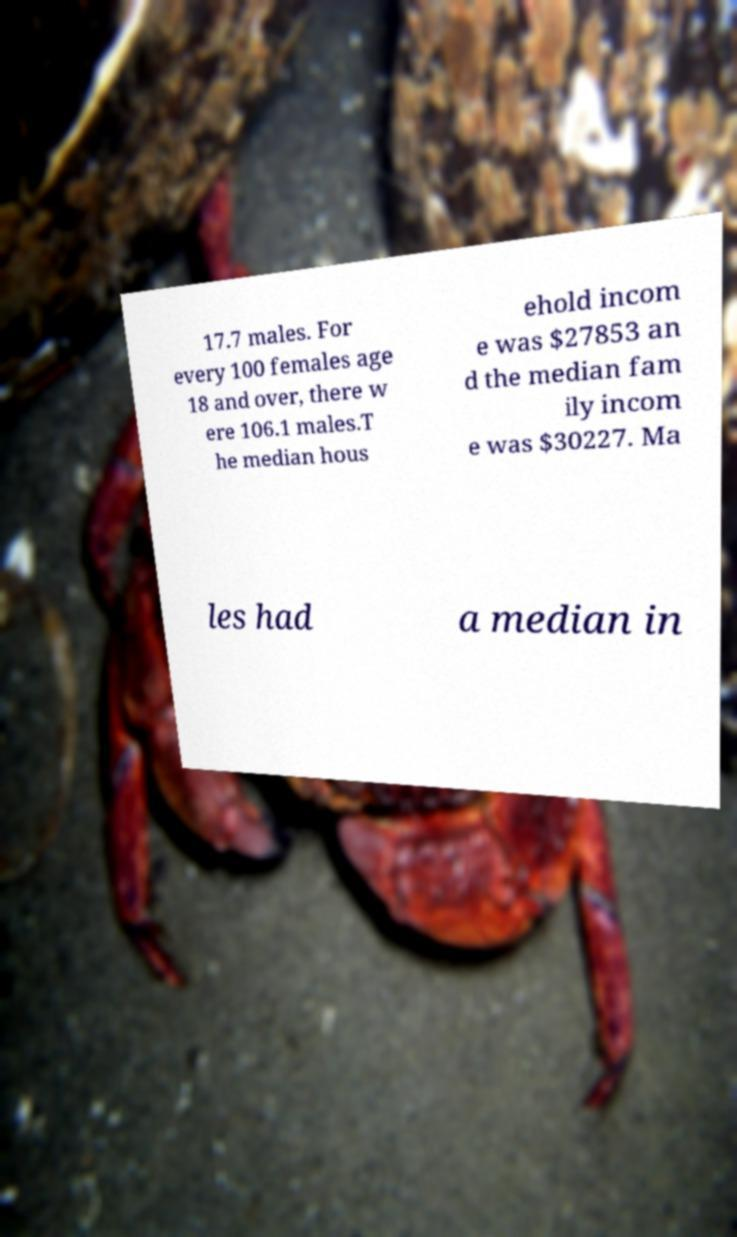Could you extract and type out the text from this image? 17.7 males. For every 100 females age 18 and over, there w ere 106.1 males.T he median hous ehold incom e was $27853 an d the median fam ily incom e was $30227. Ma les had a median in 